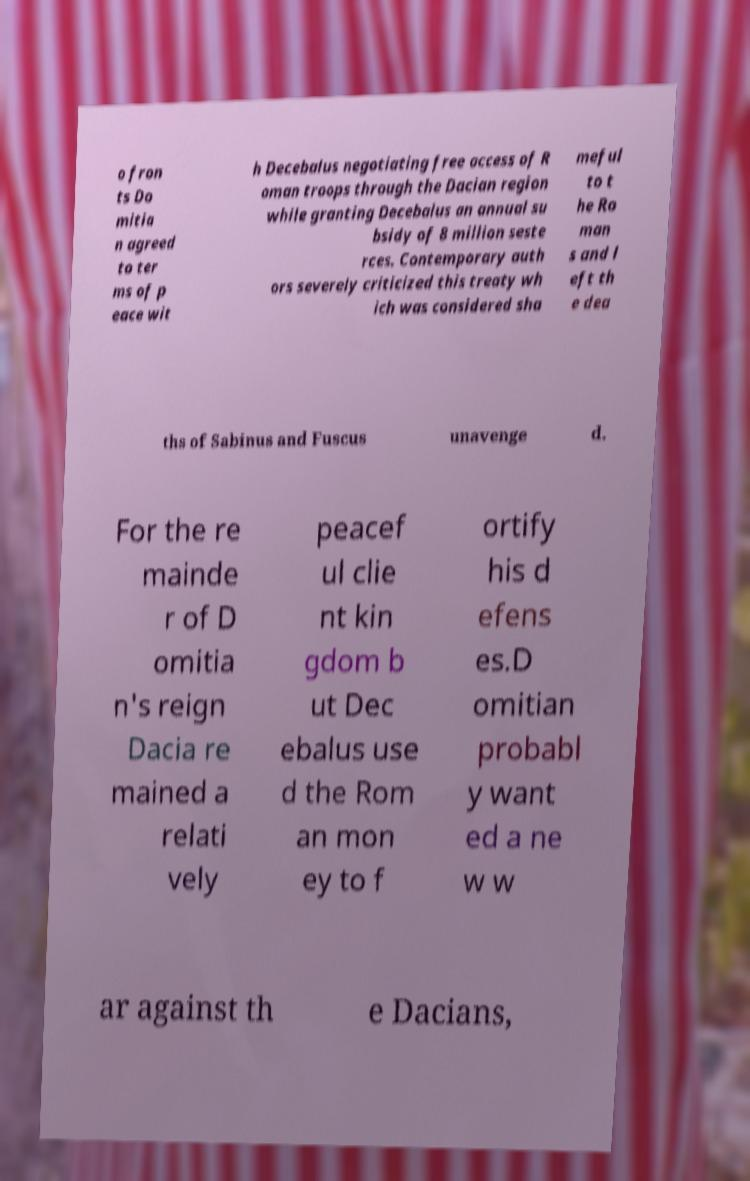Please read and relay the text visible in this image. What does it say? o fron ts Do mitia n agreed to ter ms of p eace wit h Decebalus negotiating free access of R oman troops through the Dacian region while granting Decebalus an annual su bsidy of 8 million seste rces. Contemporary auth ors severely criticized this treaty wh ich was considered sha meful to t he Ro man s and l eft th e dea ths of Sabinus and Fuscus unavenge d. For the re mainde r of D omitia n's reign Dacia re mained a relati vely peacef ul clie nt kin gdom b ut Dec ebalus use d the Rom an mon ey to f ortify his d efens es.D omitian probabl y want ed a ne w w ar against th e Dacians, 